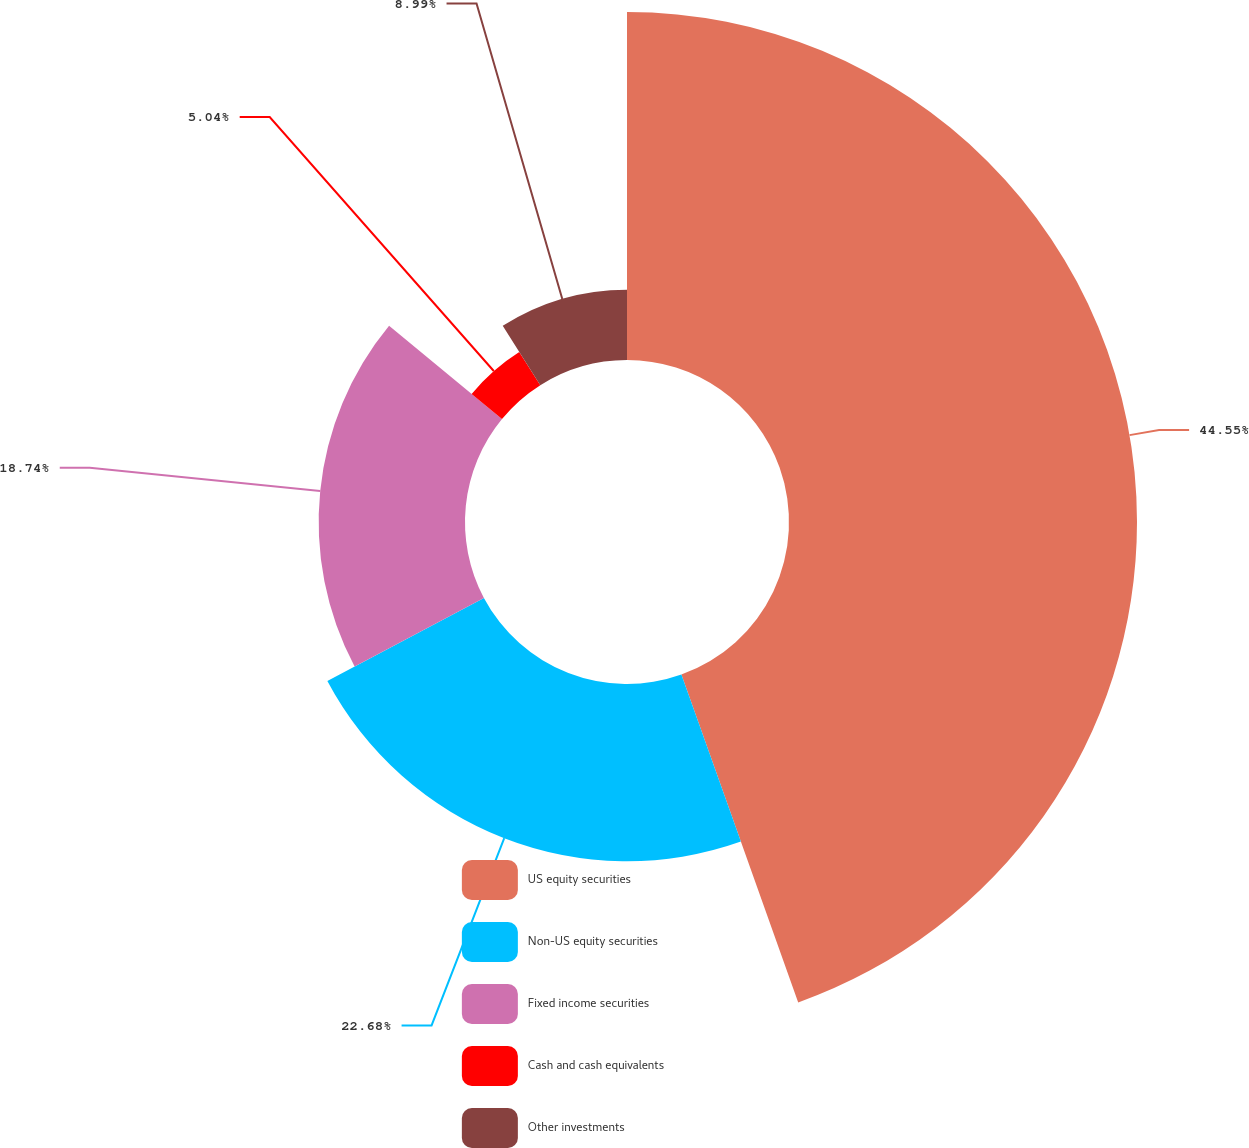Convert chart to OTSL. <chart><loc_0><loc_0><loc_500><loc_500><pie_chart><fcel>US equity securities<fcel>Non-US equity securities<fcel>Fixed income securities<fcel>Cash and cash equivalents<fcel>Other investments<nl><fcel>44.56%<fcel>22.69%<fcel>18.74%<fcel>5.04%<fcel>8.99%<nl></chart> 